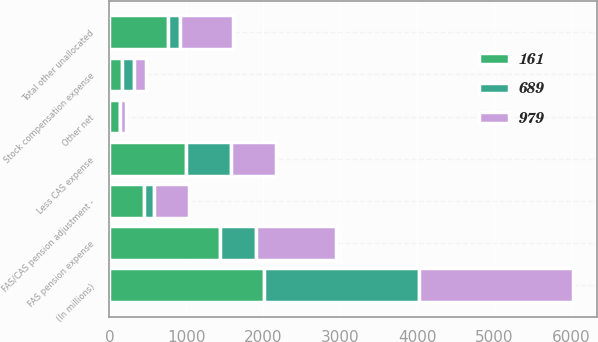Convert chart to OTSL. <chart><loc_0><loc_0><loc_500><loc_500><stacked_bar_chart><ecel><fcel>(In millions)<fcel>FAS pension expense<fcel>Less CAS expense<fcel>FAS/CAS pension adjustment -<fcel>Stock compensation expense<fcel>Other net<fcel>Total other unallocated<nl><fcel>161<fcel>2010<fcel>1442<fcel>988<fcel>454<fcel>168<fcel>137<fcel>759<nl><fcel>979<fcel>2009<fcel>1036<fcel>580<fcel>456<fcel>154<fcel>79<fcel>689<nl><fcel>689<fcel>2008<fcel>462<fcel>590<fcel>128<fcel>155<fcel>5<fcel>161<nl></chart> 